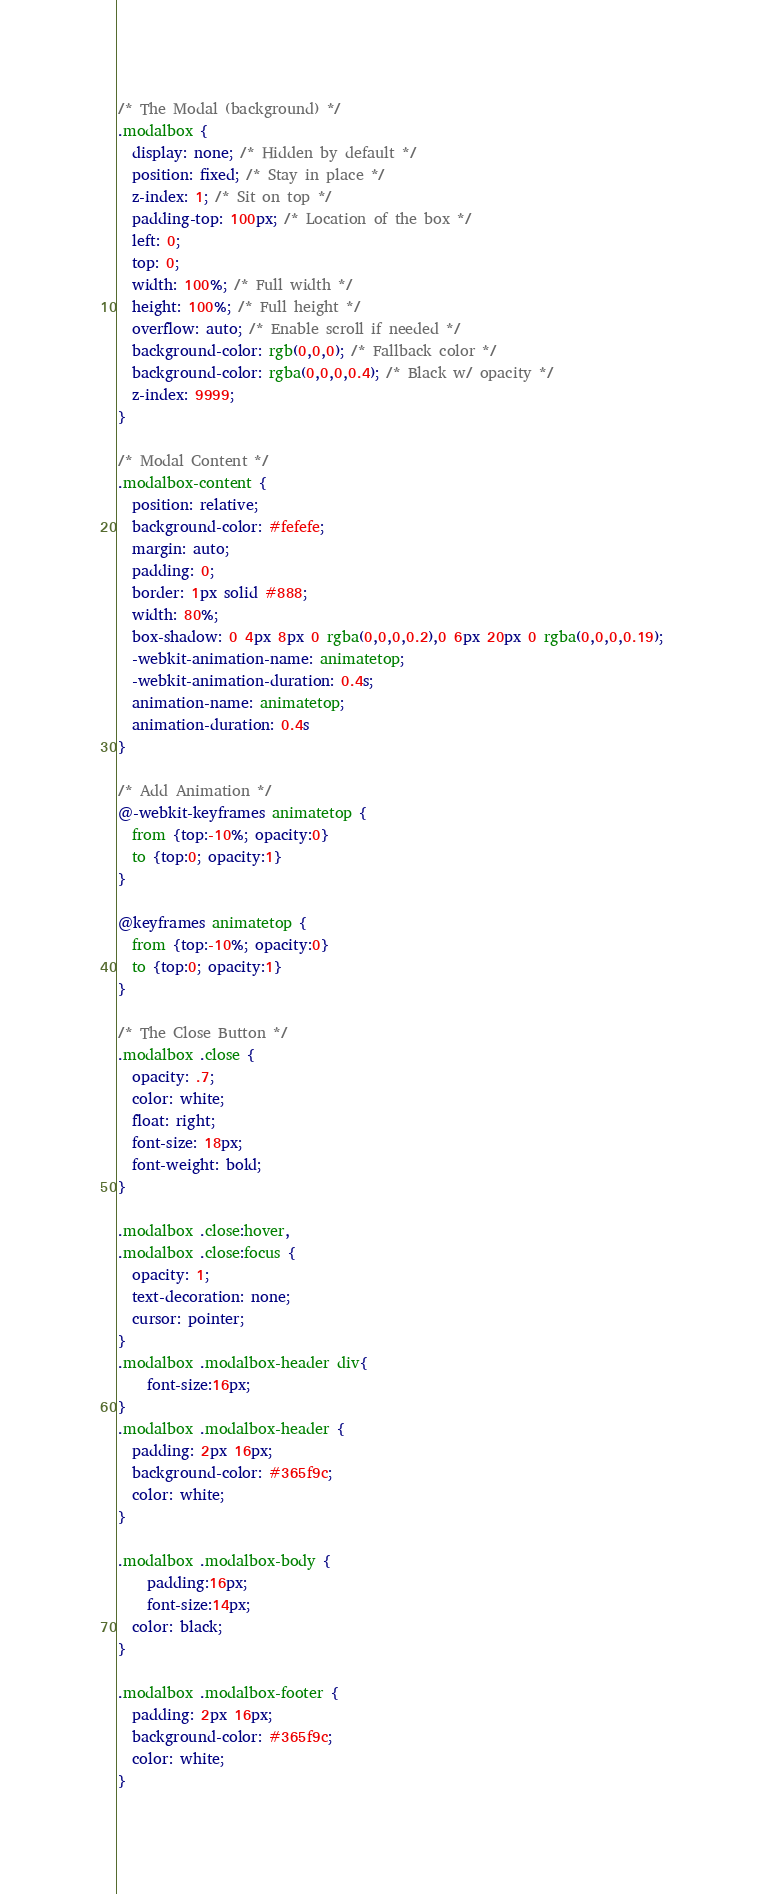<code> <loc_0><loc_0><loc_500><loc_500><_CSS_>/* The Modal (background) */
.modalbox {
  display: none; /* Hidden by default */
  position: fixed; /* Stay in place */
  z-index: 1; /* Sit on top */
  padding-top: 100px; /* Location of the box */
  left: 0;
  top: 0;
  width: 100%; /* Full width */
  height: 100%; /* Full height */
  overflow: auto; /* Enable scroll if needed */
  background-color: rgb(0,0,0); /* Fallback color */
  background-color: rgba(0,0,0,0.4); /* Black w/ opacity */
  z-index: 9999;
}

/* Modal Content */
.modalbox-content {
  position: relative;
  background-color: #fefefe;
  margin: auto;
  padding: 0;
  border: 1px solid #888;
  width: 80%;
  box-shadow: 0 4px 8px 0 rgba(0,0,0,0.2),0 6px 20px 0 rgba(0,0,0,0.19);
  -webkit-animation-name: animatetop;
  -webkit-animation-duration: 0.4s;
  animation-name: animatetop;
  animation-duration: 0.4s
}

/* Add Animation */
@-webkit-keyframes animatetop {
  from {top:-10%; opacity:0} 
  to {top:0; opacity:1}
}

@keyframes animatetop {
  from {top:-10%; opacity:0}
  to {top:0; opacity:1}
}

/* The Close Button */
.modalbox .close {
  opacity: .7;
  color: white;
  float: right;
  font-size: 18px;
  font-weight: bold;
}

.modalbox .close:hover,
.modalbox .close:focus {
  opacity: 1;
  text-decoration: none;
  cursor: pointer;
}
.modalbox .modalbox-header div{
	font-size:16px;
}
.modalbox .modalbox-header {
  padding: 2px 16px;
  background-color: #365f9c;
  color: white;
}

.modalbox .modalbox-body {
	padding:16px;
	font-size:14px;
  color: black;
}

.modalbox .modalbox-footer {
  padding: 2px 16px;
  background-color: #365f9c;
  color: white;
}</code> 